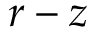Convert formula to latex. <formula><loc_0><loc_0><loc_500><loc_500>r - z</formula> 